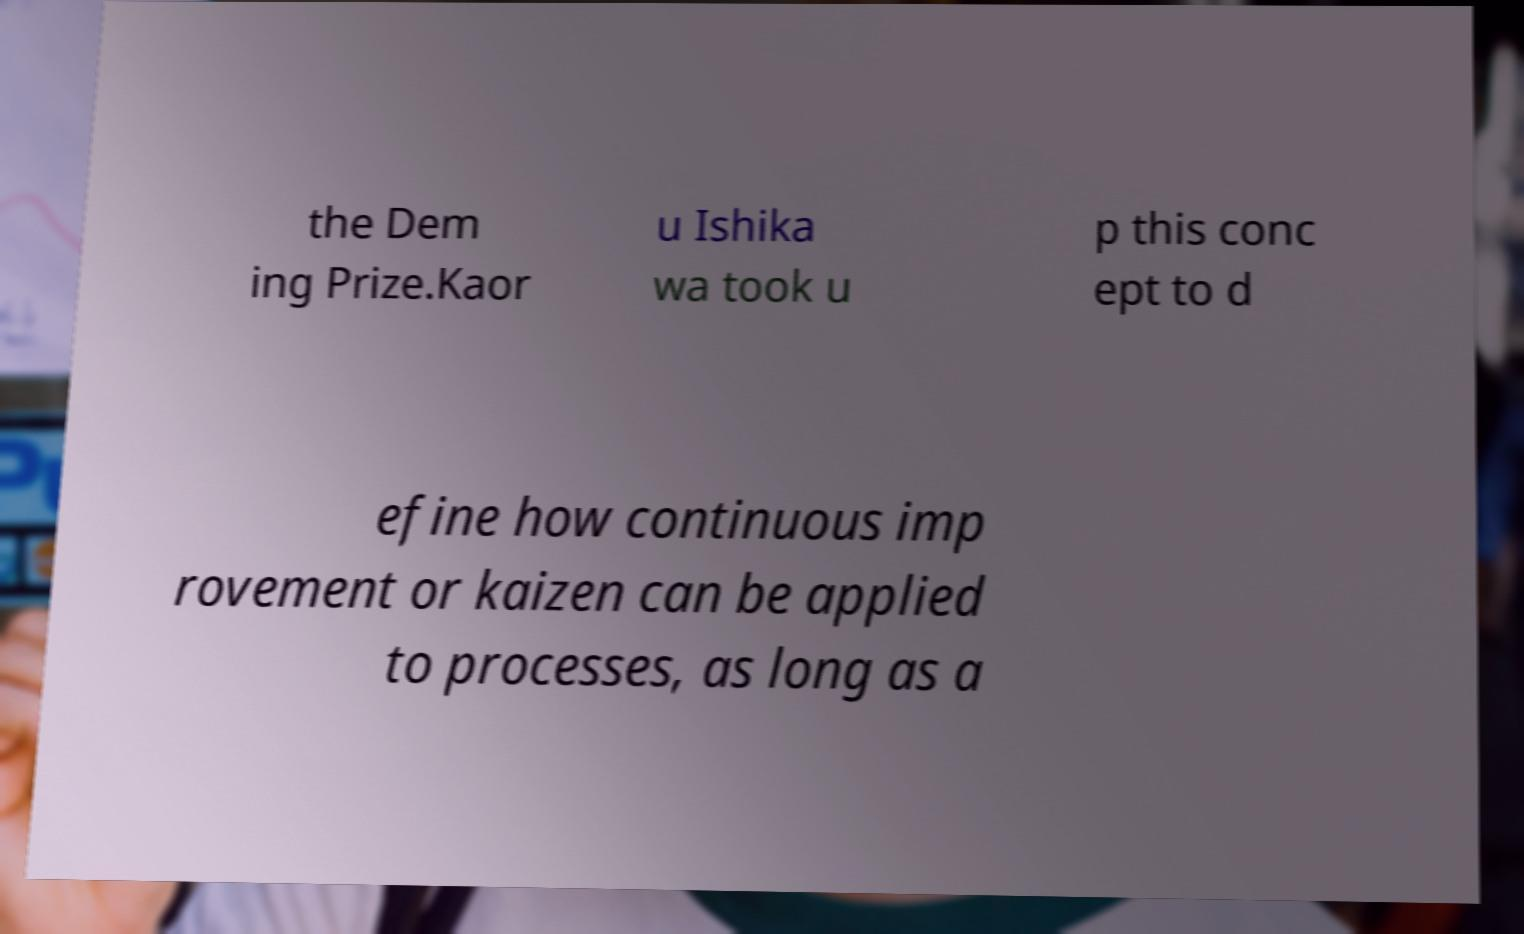Could you extract and type out the text from this image? the Dem ing Prize.Kaor u Ishika wa took u p this conc ept to d efine how continuous imp rovement or kaizen can be applied to processes, as long as a 